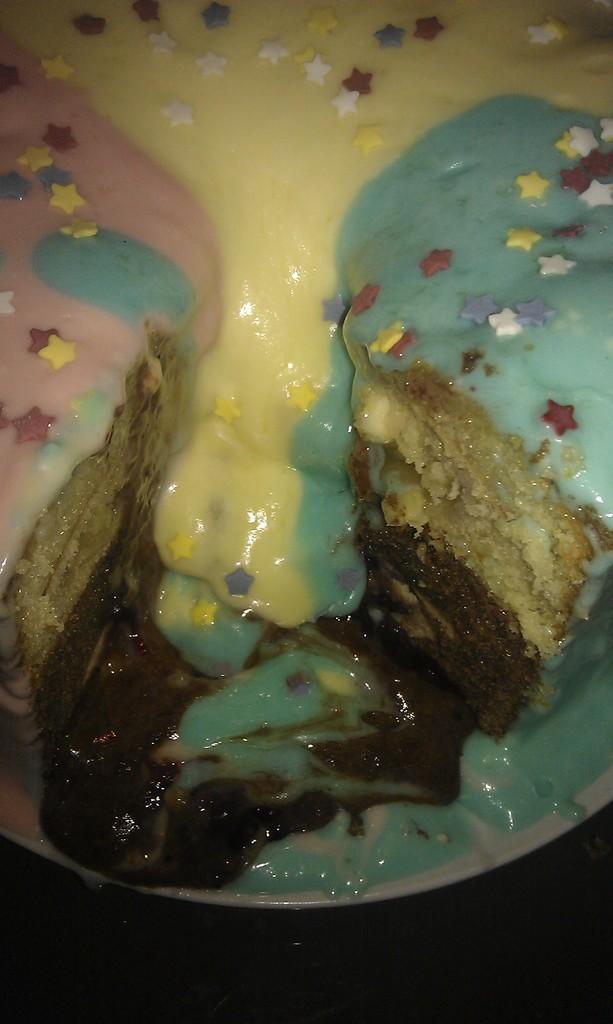Please provide a concise description of this image. In this image we can see cake in a plate and on it we can see cream. At the bottom the image is dark. 